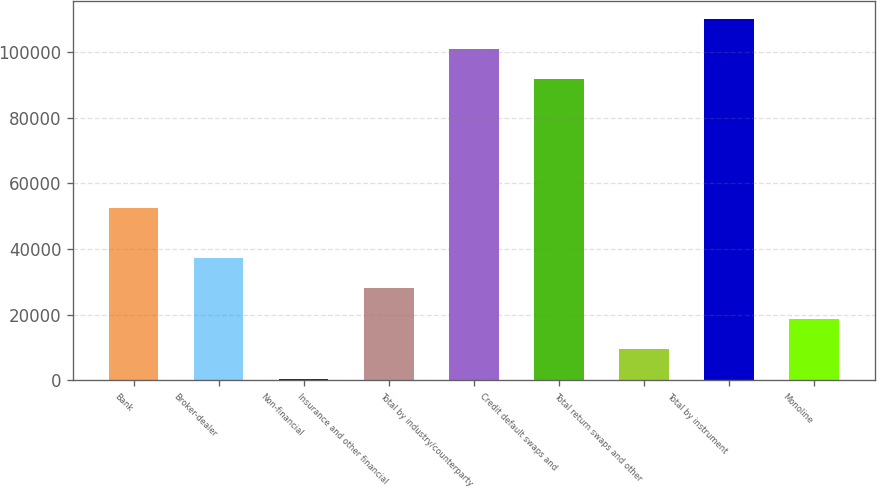Convert chart. <chart><loc_0><loc_0><loc_500><loc_500><bar_chart><fcel>Bank<fcel>Broker-dealer<fcel>Non-financial<fcel>Insurance and other financial<fcel>Total by industry/counterparty<fcel>Credit default swaps and<fcel>Total return swaps and other<fcel>Total by instrument<fcel>Monoline<nl><fcel>52383<fcel>37320.2<fcel>339<fcel>28074.9<fcel>100870<fcel>91625<fcel>9584.3<fcel>110116<fcel>18829.6<nl></chart> 